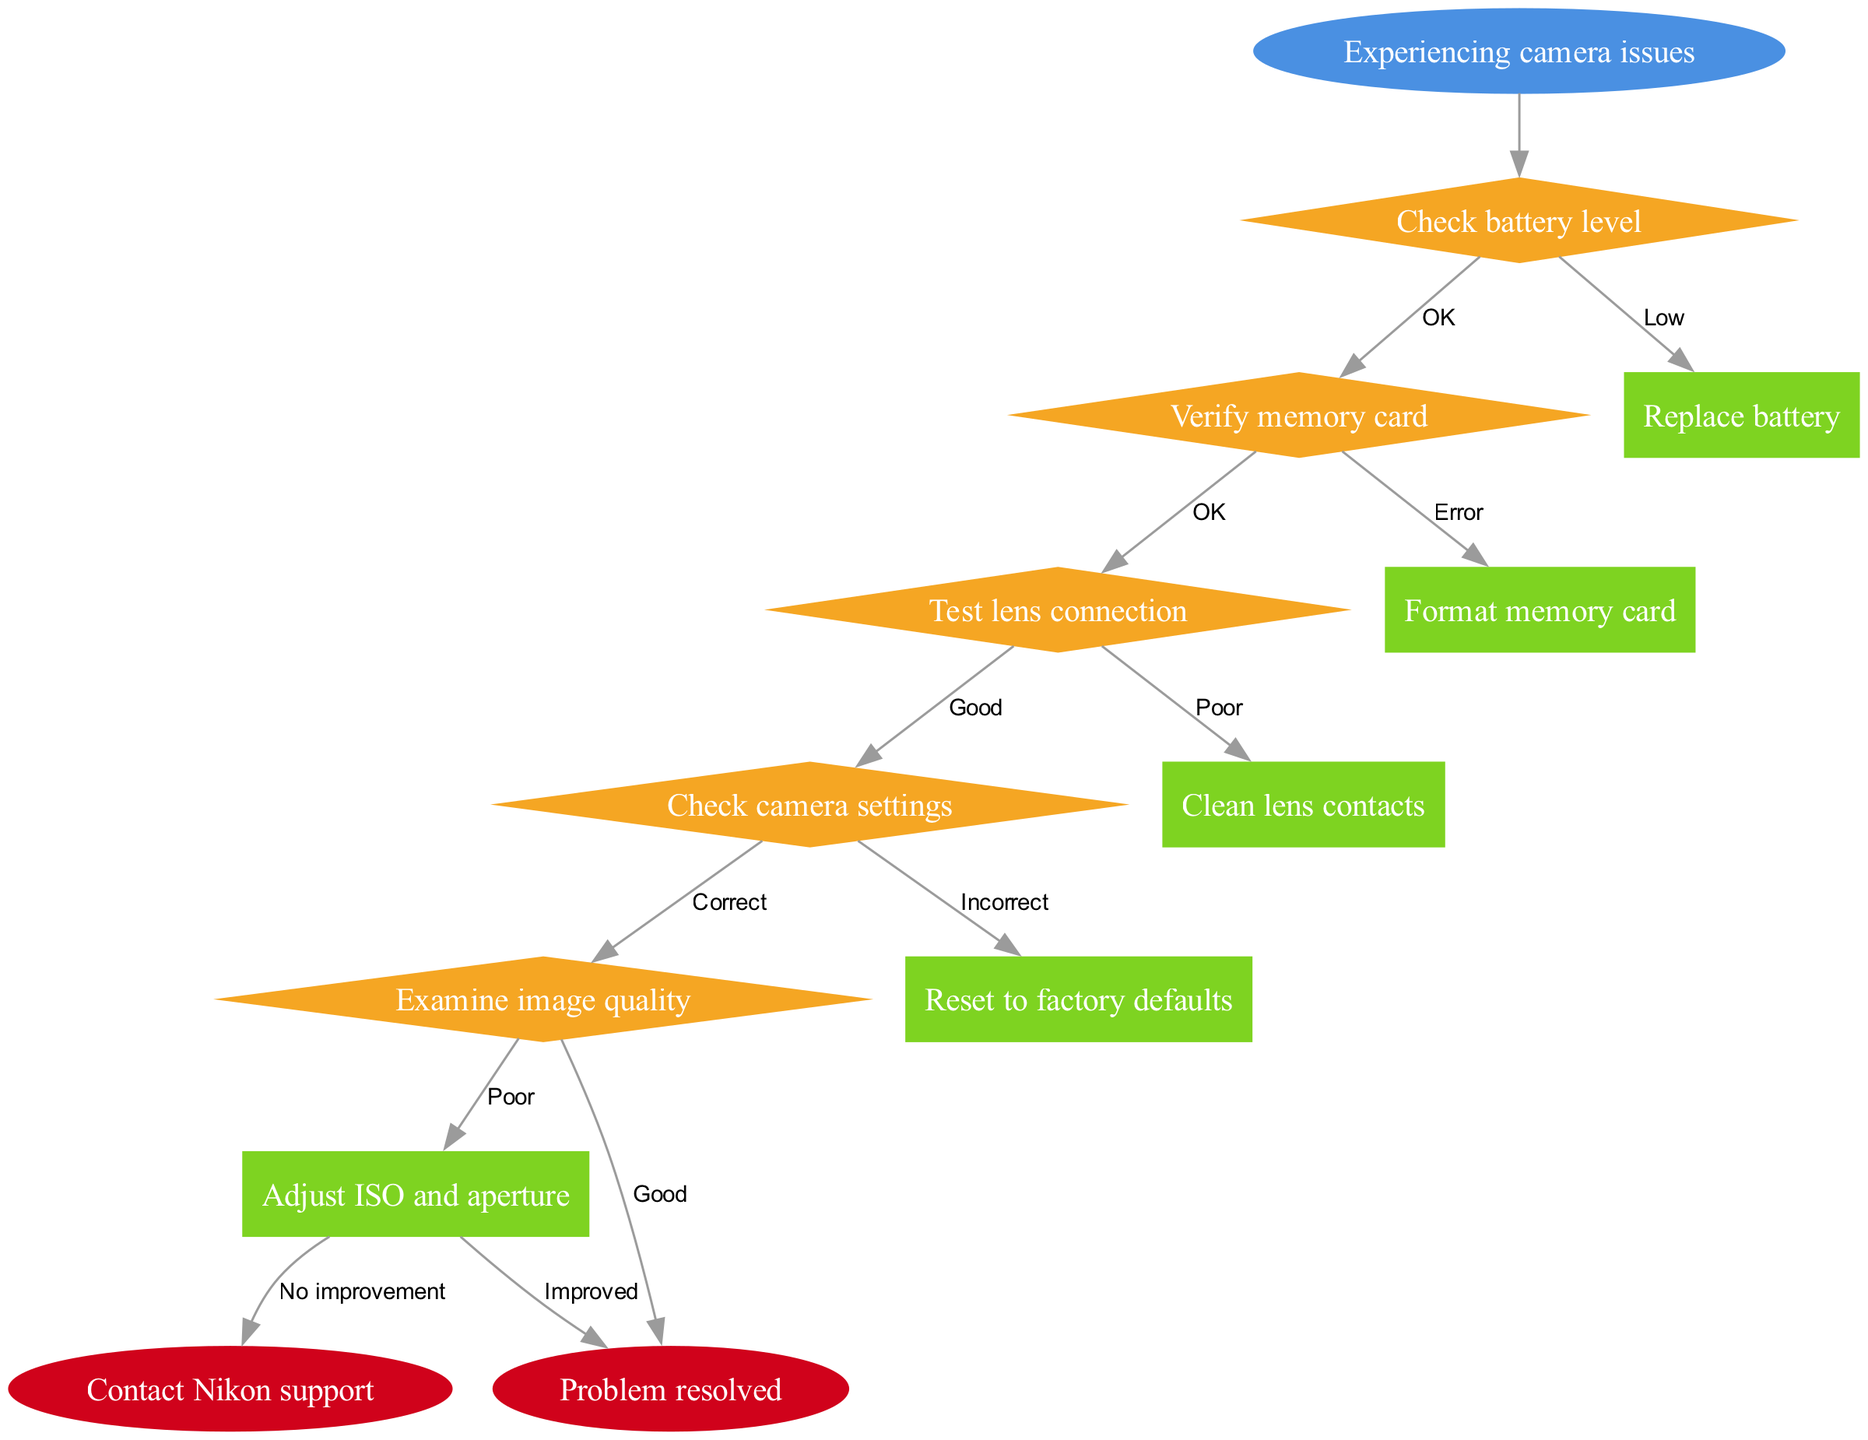What is the starting point of the flowchart? The starting point is labeled as "Experiencing camera issues," which is the first node in the diagram.
Answer: Experiencing camera issues How many decision nodes are present in the diagram? By counting the nodes labeled as diamonds, there are five decision nodes in total.
Answer: 5 What action is suggested after checking the battery level if it is low? The arrow from "Check battery level" to "Replace battery" indicates that if the battery level is low, the action is to replace the battery.
Answer: Replace battery What do you do if the memory card has an error? The flowchart shows that if the memory card has an error, you should "Format memory card" as the next action.
Answer: Format memory card What is the final outcome if the image quality is good? If the image quality is determined to be good, the next node indicates that the "Problem resolved" will follow.
Answer: Problem resolved If the lens connection is poor, what action should be taken? The flowchart directs that if the lens connection is poor, the action to take is to "Clean lens contacts."
Answer: Clean lens contacts What happens if adjusting ISO and aperture does not improve the situation? Following the path, if adjusting the ISO and aperture does not lead to improvements, the action is to "Contact Nikon support."
Answer: Contact Nikon support Which node indicates a reset action? The node saying "Reset to factory defaults" corresponds with the decision regarding camera settings deemed incorrect.
Answer: Reset to factory defaults What do you need to check after verifying the memory card is okay? After verifying the memory card is okay, the next step is to "Test lens connection."
Answer: Test lens connection 